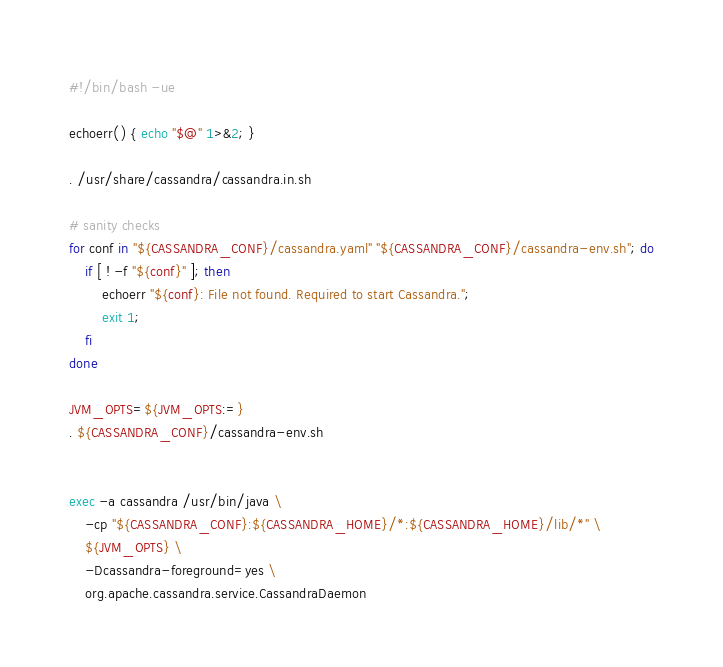<code> <loc_0><loc_0><loc_500><loc_500><_Bash_>#!/bin/bash -ue

echoerr() { echo "$@" 1>&2; }

. /usr/share/cassandra/cassandra.in.sh

# sanity checks
for conf in "${CASSANDRA_CONF}/cassandra.yaml" "${CASSANDRA_CONF}/cassandra-env.sh"; do
    if [ ! -f "${conf}" ]; then
        echoerr "${conf}: File not found. Required to start Cassandra.";
        exit 1;
    fi
done

JVM_OPTS=${JVM_OPTS:=}
. ${CASSANDRA_CONF}/cassandra-env.sh


exec -a cassandra /usr/bin/java \
    -cp "${CASSANDRA_CONF}:${CASSANDRA_HOME}/*:${CASSANDRA_HOME}/lib/*" \
    ${JVM_OPTS} \
    -Dcassandra-foreground=yes \
    org.apache.cassandra.service.CassandraDaemon</code> 